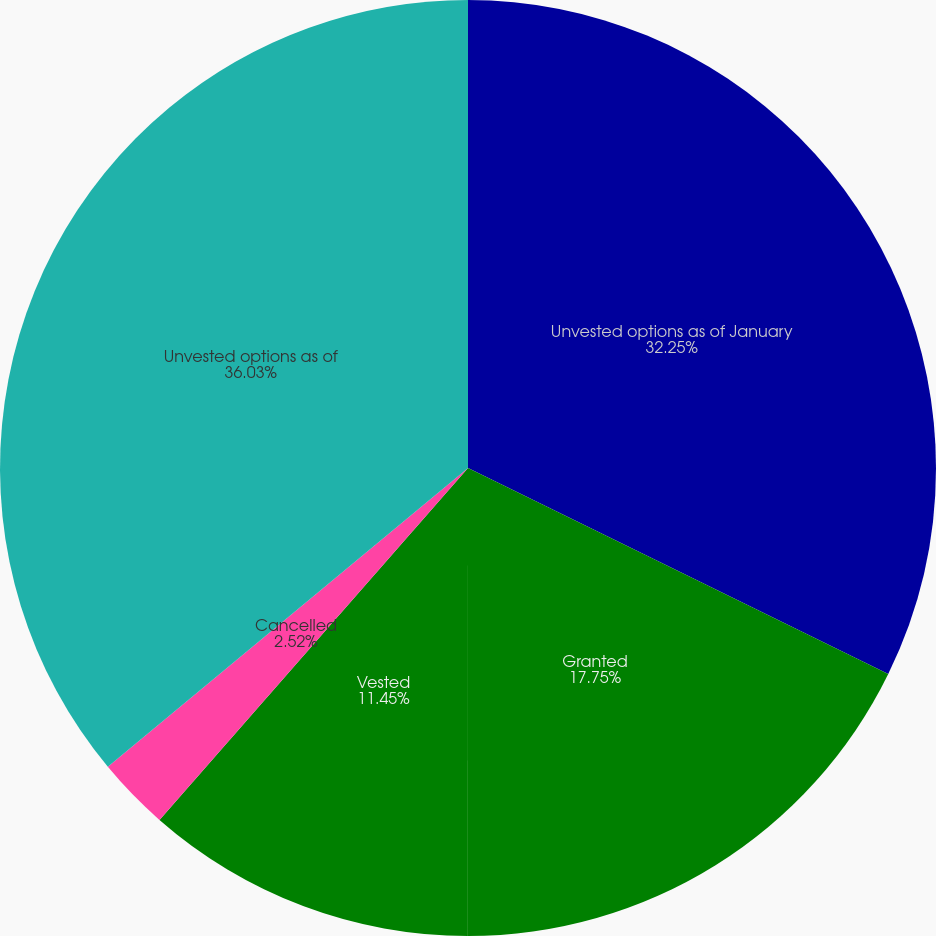<chart> <loc_0><loc_0><loc_500><loc_500><pie_chart><fcel>Unvested options as of January<fcel>Granted<fcel>Vested<fcel>Cancelled<fcel>Unvested options as of<nl><fcel>32.25%<fcel>17.75%<fcel>11.45%<fcel>2.52%<fcel>36.02%<nl></chart> 